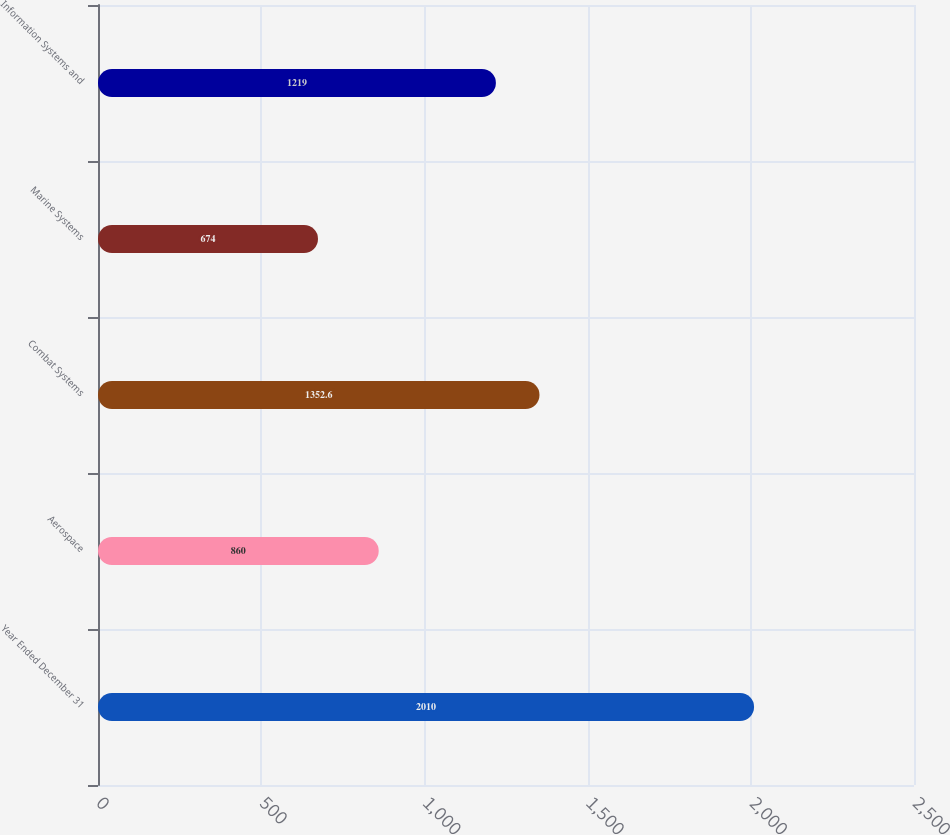Convert chart to OTSL. <chart><loc_0><loc_0><loc_500><loc_500><bar_chart><fcel>Year Ended December 31<fcel>Aerospace<fcel>Combat Systems<fcel>Marine Systems<fcel>Information Systems and<nl><fcel>2010<fcel>860<fcel>1352.6<fcel>674<fcel>1219<nl></chart> 